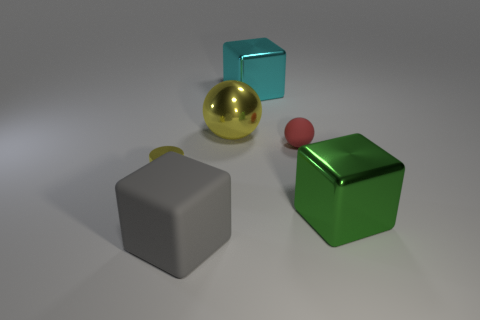Subtract all big green shiny blocks. How many blocks are left? 2 Add 2 balls. How many objects exist? 8 Subtract all cylinders. How many objects are left? 5 Subtract all small balls. Subtract all gray rubber cubes. How many objects are left? 4 Add 5 matte spheres. How many matte spheres are left? 6 Add 4 large yellow rubber blocks. How many large yellow rubber blocks exist? 4 Subtract 0 blue cylinders. How many objects are left? 6 